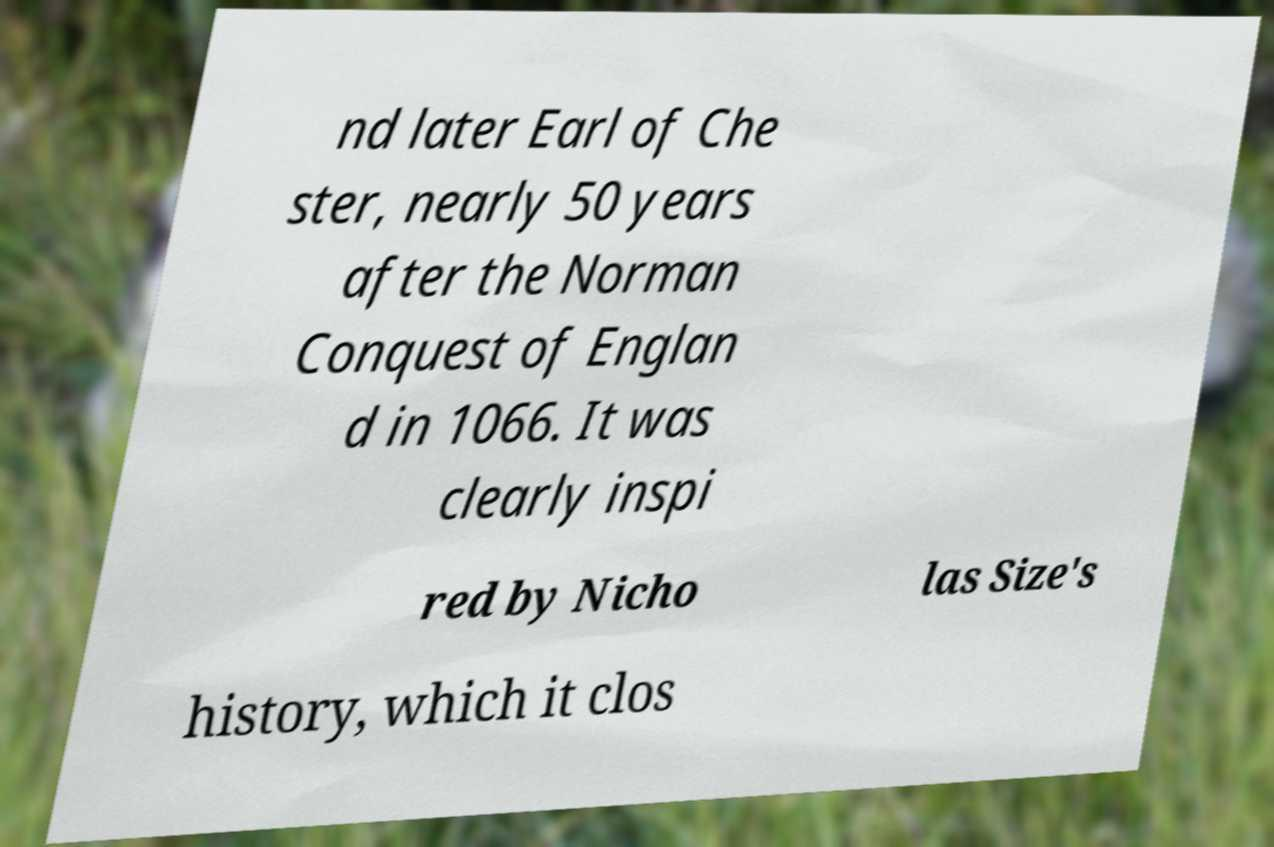Could you assist in decoding the text presented in this image and type it out clearly? nd later Earl of Che ster, nearly 50 years after the Norman Conquest of Englan d in 1066. It was clearly inspi red by Nicho las Size's history, which it clos 